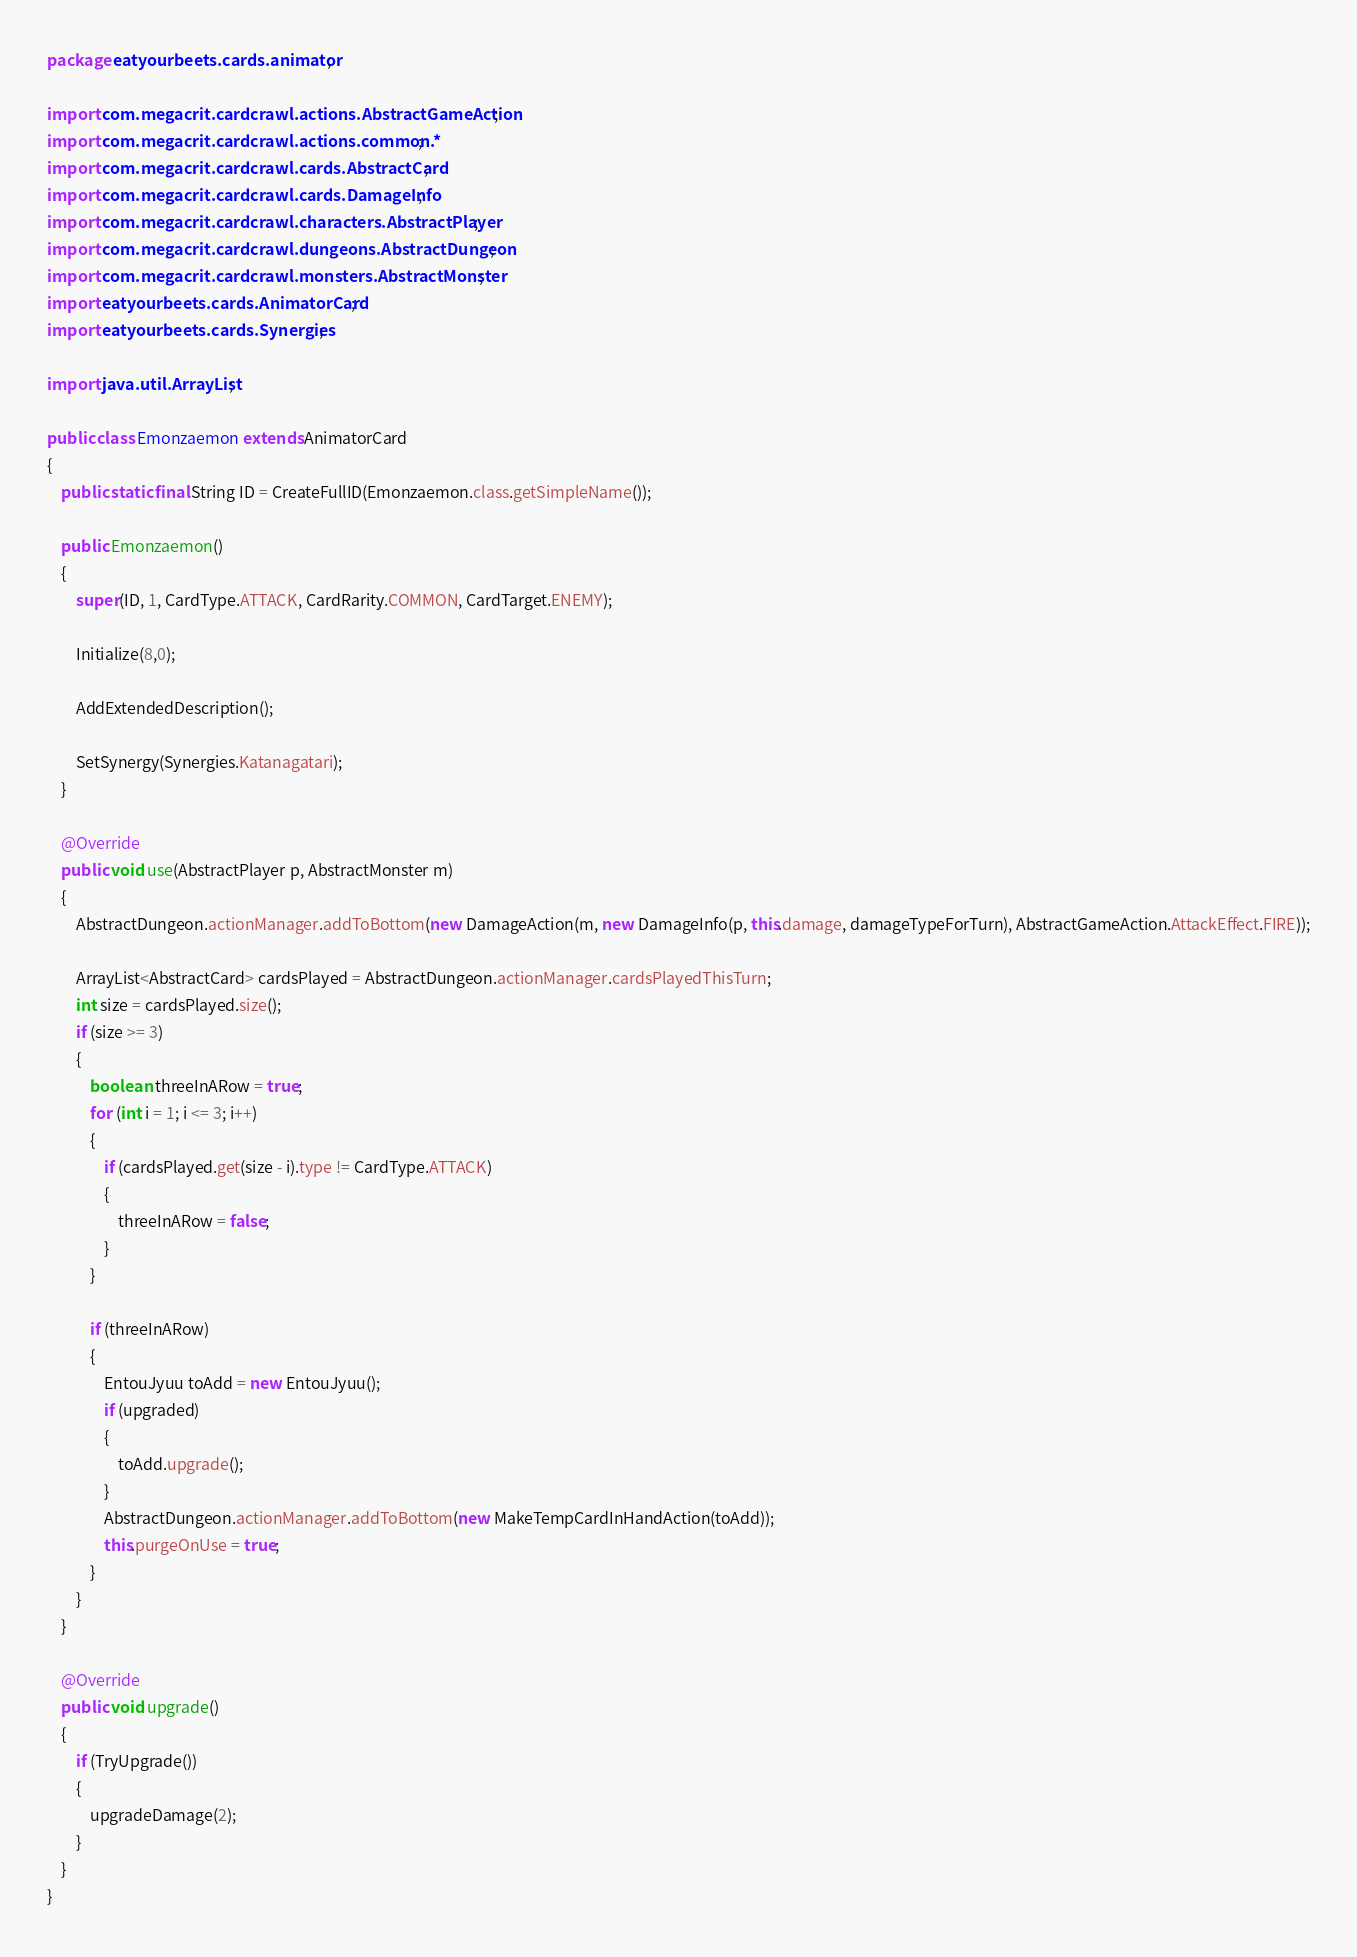<code> <loc_0><loc_0><loc_500><loc_500><_Java_>package eatyourbeets.cards.animator;

import com.megacrit.cardcrawl.actions.AbstractGameAction;
import com.megacrit.cardcrawl.actions.common.*;
import com.megacrit.cardcrawl.cards.AbstractCard;
import com.megacrit.cardcrawl.cards.DamageInfo;
import com.megacrit.cardcrawl.characters.AbstractPlayer;
import com.megacrit.cardcrawl.dungeons.AbstractDungeon;
import com.megacrit.cardcrawl.monsters.AbstractMonster;
import eatyourbeets.cards.AnimatorCard;
import eatyourbeets.cards.Synergies;

import java.util.ArrayList;

public class Emonzaemon extends AnimatorCard
{
    public static final String ID = CreateFullID(Emonzaemon.class.getSimpleName());

    public Emonzaemon()
    {
        super(ID, 1, CardType.ATTACK, CardRarity.COMMON, CardTarget.ENEMY);

        Initialize(8,0);

        AddExtendedDescription();

        SetSynergy(Synergies.Katanagatari);
    }

    @Override
    public void use(AbstractPlayer p, AbstractMonster m) 
    {
        AbstractDungeon.actionManager.addToBottom(new DamageAction(m, new DamageInfo(p, this.damage, damageTypeForTurn), AbstractGameAction.AttackEffect.FIRE));

        ArrayList<AbstractCard> cardsPlayed = AbstractDungeon.actionManager.cardsPlayedThisTurn;
        int size = cardsPlayed.size();
        if (size >= 3)
        {
            boolean threeInARow = true;
            for (int i = 1; i <= 3; i++)
            {
                if (cardsPlayed.get(size - i).type != CardType.ATTACK)
                {
                    threeInARow = false;
                }
            }

            if (threeInARow)
            {
                EntouJyuu toAdd = new EntouJyuu();
                if (upgraded)
                {
                    toAdd.upgrade();
                }
                AbstractDungeon.actionManager.addToBottom(new MakeTempCardInHandAction(toAdd));
                this.purgeOnUse = true;
            }
        }
    }

    @Override
    public void upgrade() 
    {
        if (TryUpgrade())
        {
            upgradeDamage(2);
        }
    }
}</code> 